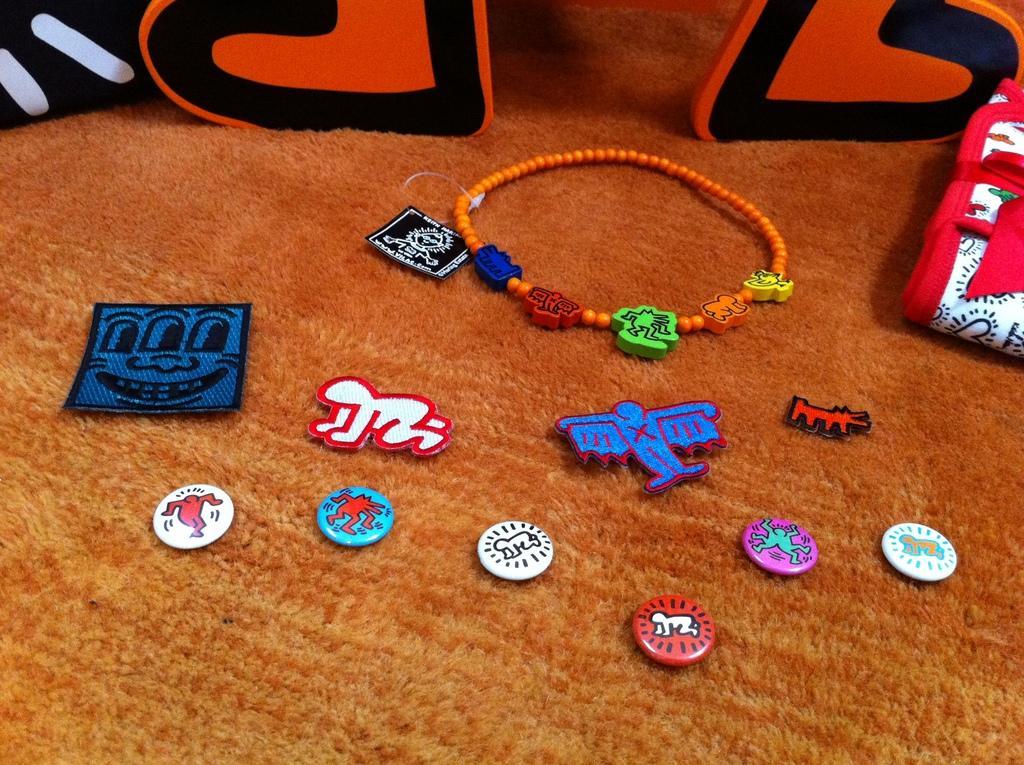Could you give a brief overview of what you see in this image? On this carpet we can see objects. 